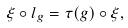<formula> <loc_0><loc_0><loc_500><loc_500>\xi \circ l _ { g } = \tau ( g ) \circ \xi ,</formula> 